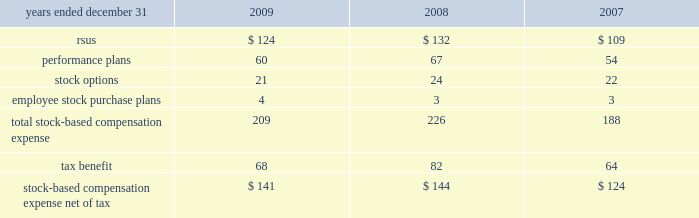14 .
Stock compensation plans the table summarizes stock-based compensation expense recognized in continuing operations in the consolidated statements of income in compensation and benefits ( in millions ) : .
During 2009 , the company converted its stock administration system to a new service provider .
In connection with this conversion , a reconciliation of the methodologies and estimates utilized was performed , which resulted in a $ 12 million reduction of expense for the year ended december 31 , 2009 .
Stock awards stock awards , in the form of rsus , are granted to certain employees and consist of both performance-based and service-based rsus .
Service-based awards generally vest between three and ten years from the date of grant .
The fair value of service-based awards is based upon the market price of the underlying common stock at the date of grant .
With certain limited exceptions , any break in continuous employment will cause the forfeiture of all unvested awards .
Compensation expense associated with stock awards is recognized over the service period using the straight-line method .
Dividend equivalents are paid on certain service-based rsus , based on the initial grant amount .
At december 31 , 2009 , 2008 and 2007 , the number of shares available for stock awards is included with options available for grant .
Performance-based rsus have been granted to certain employees .
Vesting of these awards is contingent upon meeting various individual , divisional or company-wide performance conditions , including revenue generation or growth in revenue , pretax income or earnings per share over a one- to five-year period .
The performance conditions are not considered in the determination of the grant date fair value for these awards .
The fair value of performance-based awards is based upon the market price of the underlying common stock at the date of grant .
Compensation expense is recognized over the performance period , and in certain cases an additional vesting period , based on management 2019s estimate of the number of units expected to vest .
Compensation expense is adjusted to reflect the actual number of shares paid out at the end of the programs .
The payout of shares under these performance-based plans may range from 0-200% ( 0-200 % ) of the number of units granted , based on the plan .
Dividend equivalents are generally not paid on the performance-based rsus .
During 2009 , the company granted approximately 2 million shares in connection with the completion of the 2006 leadership performance plan ( 2018 2018lpp 2019 2019 ) cycle .
During 2009 , 2008 and 2007 , the company granted approximately 3.7 million , 4.2 million and 4.3 million restricted shares , respectively , in connection with the company 2019s incentive compensation plans. .
What was the change in the stock compensation plans total stock-based compensation expense in millions from 2007 to 2008? 
Computations: (226 - 188)
Answer: 38.0. 